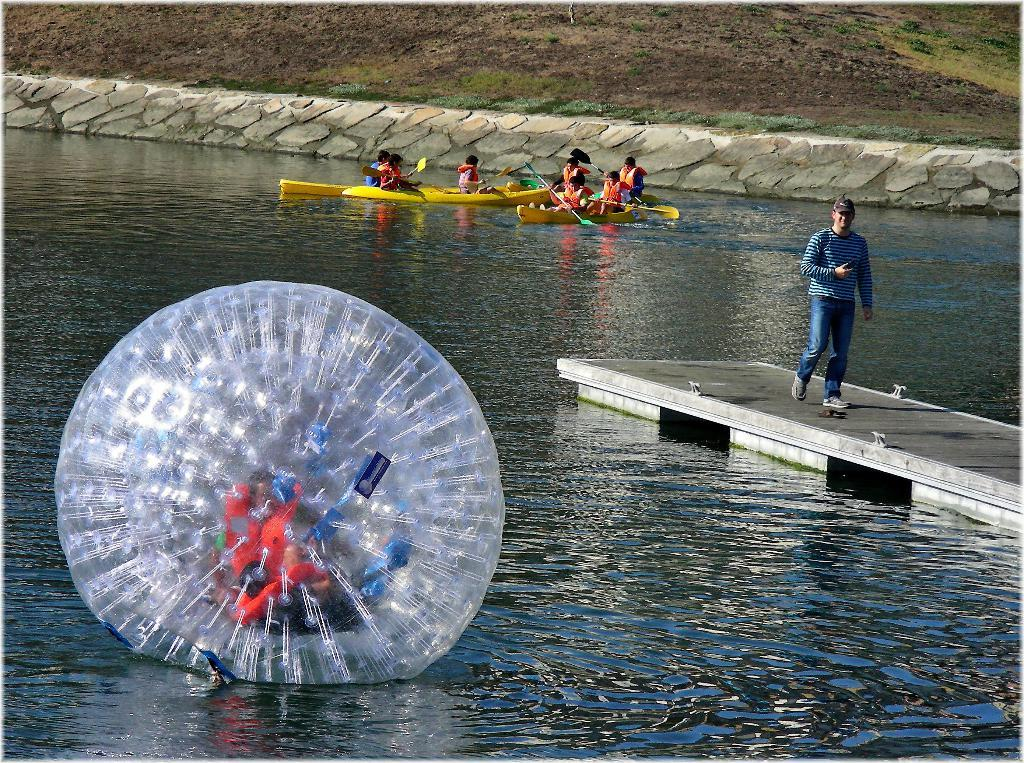What object is present in the water in the image? There is a water ball in the image. Where is the person in the image located? The person is standing on a bridge in the image. What can be seen in the background of the image? There are people sitting on a boat in the background of the image. What type of goat can be seen in the image? There is no goat present in the image. What is the temperature of the water in the image? The provided facts do not mention the temperature of the water, so it cannot be determined from the image. 